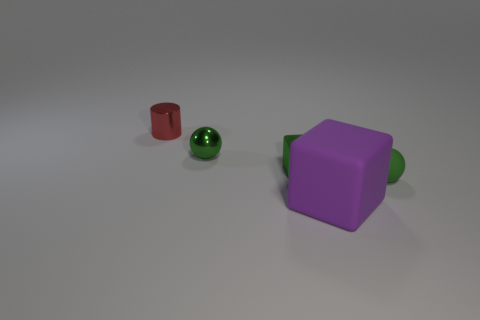Are there any other things that have the same size as the purple matte object?
Offer a very short reply. No. There is a metal thing on the right side of the ball that is behind the tiny thing right of the matte block; what is its shape?
Give a very brief answer. Cube. Are there more tiny gray metal objects than red shiny cylinders?
Keep it short and to the point. No. Is there a tiny green block?
Your answer should be very brief. Yes. How many objects are tiny metallic objects on the left side of the small block or tiny objects to the right of the green block?
Your answer should be compact. 3. Is the big rubber thing the same color as the cylinder?
Give a very brief answer. No. Is the number of small objects less than the number of small cylinders?
Make the answer very short. No. Are there any metallic cubes left of the cylinder?
Your answer should be compact. No. Is the large cube made of the same material as the small cylinder?
Make the answer very short. No. There is another object that is the same shape as the tiny green matte thing; what color is it?
Give a very brief answer. Green. 